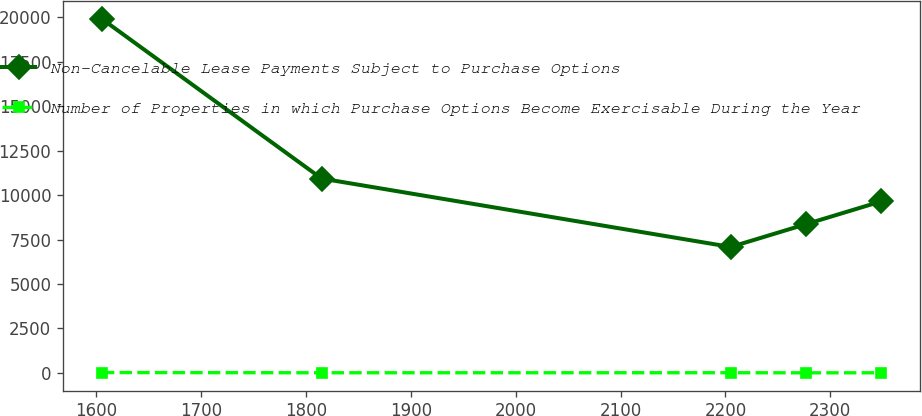Convert chart to OTSL. <chart><loc_0><loc_0><loc_500><loc_500><line_chart><ecel><fcel>Non-Cancelable Lease Payments Subject to Purchase Options<fcel>Number of Properties in which Purchase Options Become Exercisable During the Year<nl><fcel>1605.73<fcel>19907.2<fcel>21.38<nl><fcel>1815.08<fcel>10930.9<fcel>9.36<nl><fcel>2205.07<fcel>7083.95<fcel>10.93<nl><fcel>2276.82<fcel>8366.28<fcel>5.7<nl><fcel>2348.57<fcel>9648.61<fcel>7.79<nl></chart> 